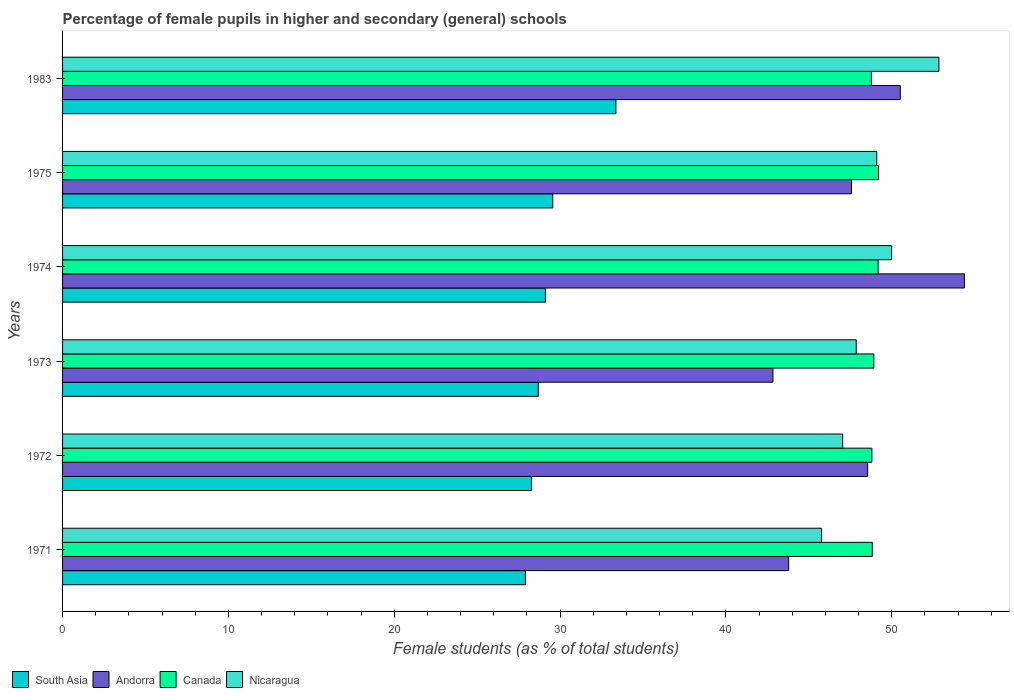Are the number of bars per tick equal to the number of legend labels?
Your response must be concise. Yes. How many bars are there on the 1st tick from the bottom?
Your answer should be compact. 4. What is the label of the 4th group of bars from the top?
Ensure brevity in your answer.  1973. What is the percentage of female pupils in higher and secondary schools in Canada in 1971?
Your answer should be compact. 48.83. Across all years, what is the maximum percentage of female pupils in higher and secondary schools in Nicaragua?
Make the answer very short. 52.85. Across all years, what is the minimum percentage of female pupils in higher and secondary schools in South Asia?
Provide a short and direct response. 27.91. In which year was the percentage of female pupils in higher and secondary schools in Canada maximum?
Ensure brevity in your answer.  1975. In which year was the percentage of female pupils in higher and secondary schools in Andorra minimum?
Offer a terse response. 1973. What is the total percentage of female pupils in higher and secondary schools in Nicaragua in the graph?
Ensure brevity in your answer.  292.6. What is the difference between the percentage of female pupils in higher and secondary schools in Canada in 1973 and that in 1983?
Make the answer very short. 0.15. What is the difference between the percentage of female pupils in higher and secondary schools in Nicaragua in 1971 and the percentage of female pupils in higher and secondary schools in Andorra in 1975?
Offer a terse response. -1.81. What is the average percentage of female pupils in higher and secondary schools in Canada per year?
Make the answer very short. 48.95. In the year 1973, what is the difference between the percentage of female pupils in higher and secondary schools in Andorra and percentage of female pupils in higher and secondary schools in South Asia?
Make the answer very short. 14.15. What is the ratio of the percentage of female pupils in higher and secondary schools in Canada in 1971 to that in 1975?
Your answer should be very brief. 0.99. Is the difference between the percentage of female pupils in higher and secondary schools in Andorra in 1971 and 1972 greater than the difference between the percentage of female pupils in higher and secondary schools in South Asia in 1971 and 1972?
Your answer should be compact. No. What is the difference between the highest and the second highest percentage of female pupils in higher and secondary schools in South Asia?
Your answer should be compact. 3.81. What is the difference between the highest and the lowest percentage of female pupils in higher and secondary schools in Nicaragua?
Make the answer very short. 7.08. In how many years, is the percentage of female pupils in higher and secondary schools in Andorra greater than the average percentage of female pupils in higher and secondary schools in Andorra taken over all years?
Make the answer very short. 3. Is it the case that in every year, the sum of the percentage of female pupils in higher and secondary schools in South Asia and percentage of female pupils in higher and secondary schools in Nicaragua is greater than the sum of percentage of female pupils in higher and secondary schools in Canada and percentage of female pupils in higher and secondary schools in Andorra?
Keep it short and to the point. Yes. What does the 3rd bar from the top in 1974 represents?
Your answer should be compact. Andorra. What does the 3rd bar from the bottom in 1983 represents?
Provide a succinct answer. Canada. Is it the case that in every year, the sum of the percentage of female pupils in higher and secondary schools in Nicaragua and percentage of female pupils in higher and secondary schools in Andorra is greater than the percentage of female pupils in higher and secondary schools in South Asia?
Give a very brief answer. Yes. How many bars are there?
Your answer should be compact. 24. Does the graph contain any zero values?
Provide a succinct answer. No. How many legend labels are there?
Ensure brevity in your answer.  4. How are the legend labels stacked?
Provide a succinct answer. Horizontal. What is the title of the graph?
Make the answer very short. Percentage of female pupils in higher and secondary (general) schools. What is the label or title of the X-axis?
Your answer should be very brief. Female students (as % of total students). What is the label or title of the Y-axis?
Keep it short and to the point. Years. What is the Female students (as % of total students) of South Asia in 1971?
Provide a succinct answer. 27.91. What is the Female students (as % of total students) in Andorra in 1971?
Keep it short and to the point. 43.78. What is the Female students (as % of total students) in Canada in 1971?
Give a very brief answer. 48.83. What is the Female students (as % of total students) of Nicaragua in 1971?
Your answer should be compact. 45.76. What is the Female students (as % of total students) of South Asia in 1972?
Provide a short and direct response. 28.27. What is the Female students (as % of total students) in Andorra in 1972?
Make the answer very short. 48.55. What is the Female students (as % of total students) of Canada in 1972?
Your answer should be compact. 48.8. What is the Female students (as % of total students) of Nicaragua in 1972?
Offer a terse response. 47.04. What is the Female students (as % of total students) of South Asia in 1973?
Your answer should be compact. 28.69. What is the Female students (as % of total students) of Andorra in 1973?
Ensure brevity in your answer.  42.84. What is the Female students (as % of total students) of Canada in 1973?
Give a very brief answer. 48.92. What is the Female students (as % of total students) in Nicaragua in 1973?
Your response must be concise. 47.86. What is the Female students (as % of total students) of South Asia in 1974?
Keep it short and to the point. 29.12. What is the Female students (as % of total students) of Andorra in 1974?
Provide a succinct answer. 54.38. What is the Female students (as % of total students) of Canada in 1974?
Give a very brief answer. 49.18. What is the Female students (as % of total students) in Nicaragua in 1974?
Offer a terse response. 49.99. What is the Female students (as % of total students) in South Asia in 1975?
Your answer should be very brief. 29.56. What is the Female students (as % of total students) of Andorra in 1975?
Make the answer very short. 47.57. What is the Female students (as % of total students) of Canada in 1975?
Provide a succinct answer. 49.21. What is the Female students (as % of total students) in Nicaragua in 1975?
Provide a succinct answer. 49.1. What is the Female students (as % of total students) in South Asia in 1983?
Provide a short and direct response. 33.37. What is the Female students (as % of total students) in Andorra in 1983?
Give a very brief answer. 50.52. What is the Female students (as % of total students) in Canada in 1983?
Provide a succinct answer. 48.77. What is the Female students (as % of total students) of Nicaragua in 1983?
Your response must be concise. 52.85. Across all years, what is the maximum Female students (as % of total students) in South Asia?
Ensure brevity in your answer.  33.37. Across all years, what is the maximum Female students (as % of total students) of Andorra?
Give a very brief answer. 54.38. Across all years, what is the maximum Female students (as % of total students) in Canada?
Ensure brevity in your answer.  49.21. Across all years, what is the maximum Female students (as % of total students) of Nicaragua?
Give a very brief answer. 52.85. Across all years, what is the minimum Female students (as % of total students) in South Asia?
Give a very brief answer. 27.91. Across all years, what is the minimum Female students (as % of total students) in Andorra?
Your answer should be compact. 42.84. Across all years, what is the minimum Female students (as % of total students) in Canada?
Offer a very short reply. 48.77. Across all years, what is the minimum Female students (as % of total students) in Nicaragua?
Make the answer very short. 45.76. What is the total Female students (as % of total students) of South Asia in the graph?
Offer a very short reply. 176.92. What is the total Female students (as % of total students) in Andorra in the graph?
Ensure brevity in your answer.  287.64. What is the total Female students (as % of total students) of Canada in the graph?
Offer a terse response. 293.71. What is the total Female students (as % of total students) in Nicaragua in the graph?
Give a very brief answer. 292.6. What is the difference between the Female students (as % of total students) in South Asia in 1971 and that in 1972?
Give a very brief answer. -0.36. What is the difference between the Female students (as % of total students) of Andorra in 1971 and that in 1972?
Your answer should be very brief. -4.76. What is the difference between the Female students (as % of total students) of Canada in 1971 and that in 1972?
Make the answer very short. 0.03. What is the difference between the Female students (as % of total students) in Nicaragua in 1971 and that in 1972?
Offer a terse response. -1.28. What is the difference between the Female students (as % of total students) in South Asia in 1971 and that in 1973?
Offer a very short reply. -0.78. What is the difference between the Female students (as % of total students) in Andorra in 1971 and that in 1973?
Give a very brief answer. 0.95. What is the difference between the Female students (as % of total students) of Canada in 1971 and that in 1973?
Offer a very short reply. -0.09. What is the difference between the Female students (as % of total students) in Nicaragua in 1971 and that in 1973?
Ensure brevity in your answer.  -2.09. What is the difference between the Female students (as % of total students) of South Asia in 1971 and that in 1974?
Your answer should be very brief. -1.21. What is the difference between the Female students (as % of total students) of Andorra in 1971 and that in 1974?
Your answer should be compact. -10.6. What is the difference between the Female students (as % of total students) of Canada in 1971 and that in 1974?
Provide a succinct answer. -0.35. What is the difference between the Female students (as % of total students) in Nicaragua in 1971 and that in 1974?
Provide a short and direct response. -4.23. What is the difference between the Female students (as % of total students) of South Asia in 1971 and that in 1975?
Your answer should be very brief. -1.65. What is the difference between the Female students (as % of total students) in Andorra in 1971 and that in 1975?
Your answer should be very brief. -3.79. What is the difference between the Female students (as % of total students) in Canada in 1971 and that in 1975?
Keep it short and to the point. -0.38. What is the difference between the Female students (as % of total students) in Nicaragua in 1971 and that in 1975?
Provide a short and direct response. -3.33. What is the difference between the Female students (as % of total students) in South Asia in 1971 and that in 1983?
Offer a very short reply. -5.46. What is the difference between the Female students (as % of total students) in Andorra in 1971 and that in 1983?
Provide a short and direct response. -6.73. What is the difference between the Female students (as % of total students) in Canada in 1971 and that in 1983?
Make the answer very short. 0.06. What is the difference between the Female students (as % of total students) in Nicaragua in 1971 and that in 1983?
Offer a very short reply. -7.08. What is the difference between the Female students (as % of total students) in South Asia in 1972 and that in 1973?
Ensure brevity in your answer.  -0.41. What is the difference between the Female students (as % of total students) in Andorra in 1972 and that in 1973?
Give a very brief answer. 5.71. What is the difference between the Female students (as % of total students) in Canada in 1972 and that in 1973?
Offer a very short reply. -0.12. What is the difference between the Female students (as % of total students) in Nicaragua in 1972 and that in 1973?
Your response must be concise. -0.82. What is the difference between the Female students (as % of total students) of South Asia in 1972 and that in 1974?
Your answer should be very brief. -0.84. What is the difference between the Female students (as % of total students) of Andorra in 1972 and that in 1974?
Offer a very short reply. -5.83. What is the difference between the Female students (as % of total students) of Canada in 1972 and that in 1974?
Your response must be concise. -0.38. What is the difference between the Female students (as % of total students) of Nicaragua in 1972 and that in 1974?
Your answer should be very brief. -2.95. What is the difference between the Female students (as % of total students) in South Asia in 1972 and that in 1975?
Your answer should be very brief. -1.29. What is the difference between the Female students (as % of total students) in Andorra in 1972 and that in 1975?
Make the answer very short. 0.97. What is the difference between the Female students (as % of total students) in Canada in 1972 and that in 1975?
Make the answer very short. -0.4. What is the difference between the Female students (as % of total students) of Nicaragua in 1972 and that in 1975?
Make the answer very short. -2.06. What is the difference between the Female students (as % of total students) of South Asia in 1972 and that in 1983?
Provide a succinct answer. -5.09. What is the difference between the Female students (as % of total students) in Andorra in 1972 and that in 1983?
Your answer should be compact. -1.97. What is the difference between the Female students (as % of total students) of Canada in 1972 and that in 1983?
Provide a short and direct response. 0.03. What is the difference between the Female students (as % of total students) of Nicaragua in 1972 and that in 1983?
Ensure brevity in your answer.  -5.8. What is the difference between the Female students (as % of total students) in South Asia in 1973 and that in 1974?
Give a very brief answer. -0.43. What is the difference between the Female students (as % of total students) in Andorra in 1973 and that in 1974?
Your answer should be very brief. -11.55. What is the difference between the Female students (as % of total students) of Canada in 1973 and that in 1974?
Provide a succinct answer. -0.26. What is the difference between the Female students (as % of total students) of Nicaragua in 1973 and that in 1974?
Offer a very short reply. -2.13. What is the difference between the Female students (as % of total students) in South Asia in 1973 and that in 1975?
Offer a very short reply. -0.87. What is the difference between the Female students (as % of total students) in Andorra in 1973 and that in 1975?
Keep it short and to the point. -4.74. What is the difference between the Female students (as % of total students) of Canada in 1973 and that in 1975?
Provide a succinct answer. -0.28. What is the difference between the Female students (as % of total students) of Nicaragua in 1973 and that in 1975?
Keep it short and to the point. -1.24. What is the difference between the Female students (as % of total students) of South Asia in 1973 and that in 1983?
Provide a short and direct response. -4.68. What is the difference between the Female students (as % of total students) in Andorra in 1973 and that in 1983?
Make the answer very short. -7.68. What is the difference between the Female students (as % of total students) in Canada in 1973 and that in 1983?
Your answer should be very brief. 0.15. What is the difference between the Female students (as % of total students) of Nicaragua in 1973 and that in 1983?
Your answer should be very brief. -4.99. What is the difference between the Female students (as % of total students) in South Asia in 1974 and that in 1975?
Make the answer very short. -0.44. What is the difference between the Female students (as % of total students) of Andorra in 1974 and that in 1975?
Make the answer very short. 6.81. What is the difference between the Female students (as % of total students) in Canada in 1974 and that in 1975?
Your answer should be compact. -0.03. What is the difference between the Female students (as % of total students) of Nicaragua in 1974 and that in 1975?
Offer a terse response. 0.9. What is the difference between the Female students (as % of total students) of South Asia in 1974 and that in 1983?
Offer a terse response. -4.25. What is the difference between the Female students (as % of total students) of Andorra in 1974 and that in 1983?
Offer a very short reply. 3.87. What is the difference between the Female students (as % of total students) of Canada in 1974 and that in 1983?
Offer a very short reply. 0.41. What is the difference between the Female students (as % of total students) of Nicaragua in 1974 and that in 1983?
Your answer should be compact. -2.85. What is the difference between the Female students (as % of total students) of South Asia in 1975 and that in 1983?
Make the answer very short. -3.81. What is the difference between the Female students (as % of total students) of Andorra in 1975 and that in 1983?
Give a very brief answer. -2.94. What is the difference between the Female students (as % of total students) of Canada in 1975 and that in 1983?
Offer a terse response. 0.43. What is the difference between the Female students (as % of total students) in Nicaragua in 1975 and that in 1983?
Provide a short and direct response. -3.75. What is the difference between the Female students (as % of total students) of South Asia in 1971 and the Female students (as % of total students) of Andorra in 1972?
Offer a terse response. -20.64. What is the difference between the Female students (as % of total students) of South Asia in 1971 and the Female students (as % of total students) of Canada in 1972?
Offer a terse response. -20.89. What is the difference between the Female students (as % of total students) in South Asia in 1971 and the Female students (as % of total students) in Nicaragua in 1972?
Give a very brief answer. -19.13. What is the difference between the Female students (as % of total students) in Andorra in 1971 and the Female students (as % of total students) in Canada in 1972?
Offer a very short reply. -5.02. What is the difference between the Female students (as % of total students) in Andorra in 1971 and the Female students (as % of total students) in Nicaragua in 1972?
Your answer should be very brief. -3.26. What is the difference between the Female students (as % of total students) of Canada in 1971 and the Female students (as % of total students) of Nicaragua in 1972?
Ensure brevity in your answer.  1.79. What is the difference between the Female students (as % of total students) in South Asia in 1971 and the Female students (as % of total students) in Andorra in 1973?
Ensure brevity in your answer.  -14.93. What is the difference between the Female students (as % of total students) in South Asia in 1971 and the Female students (as % of total students) in Canada in 1973?
Ensure brevity in your answer.  -21.01. What is the difference between the Female students (as % of total students) in South Asia in 1971 and the Female students (as % of total students) in Nicaragua in 1973?
Make the answer very short. -19.95. What is the difference between the Female students (as % of total students) in Andorra in 1971 and the Female students (as % of total students) in Canada in 1973?
Make the answer very short. -5.14. What is the difference between the Female students (as % of total students) of Andorra in 1971 and the Female students (as % of total students) of Nicaragua in 1973?
Offer a terse response. -4.07. What is the difference between the Female students (as % of total students) in Canada in 1971 and the Female students (as % of total students) in Nicaragua in 1973?
Keep it short and to the point. 0.97. What is the difference between the Female students (as % of total students) in South Asia in 1971 and the Female students (as % of total students) in Andorra in 1974?
Make the answer very short. -26.47. What is the difference between the Female students (as % of total students) of South Asia in 1971 and the Female students (as % of total students) of Canada in 1974?
Provide a succinct answer. -21.27. What is the difference between the Female students (as % of total students) of South Asia in 1971 and the Female students (as % of total students) of Nicaragua in 1974?
Your response must be concise. -22.08. What is the difference between the Female students (as % of total students) in Andorra in 1971 and the Female students (as % of total students) in Canada in 1974?
Your answer should be very brief. -5.4. What is the difference between the Female students (as % of total students) in Andorra in 1971 and the Female students (as % of total students) in Nicaragua in 1974?
Your answer should be very brief. -6.21. What is the difference between the Female students (as % of total students) of Canada in 1971 and the Female students (as % of total students) of Nicaragua in 1974?
Make the answer very short. -1.16. What is the difference between the Female students (as % of total students) in South Asia in 1971 and the Female students (as % of total students) in Andorra in 1975?
Keep it short and to the point. -19.66. What is the difference between the Female students (as % of total students) of South Asia in 1971 and the Female students (as % of total students) of Canada in 1975?
Your response must be concise. -21.29. What is the difference between the Female students (as % of total students) of South Asia in 1971 and the Female students (as % of total students) of Nicaragua in 1975?
Make the answer very short. -21.19. What is the difference between the Female students (as % of total students) in Andorra in 1971 and the Female students (as % of total students) in Canada in 1975?
Offer a terse response. -5.42. What is the difference between the Female students (as % of total students) in Andorra in 1971 and the Female students (as % of total students) in Nicaragua in 1975?
Provide a short and direct response. -5.31. What is the difference between the Female students (as % of total students) in Canada in 1971 and the Female students (as % of total students) in Nicaragua in 1975?
Make the answer very short. -0.27. What is the difference between the Female students (as % of total students) in South Asia in 1971 and the Female students (as % of total students) in Andorra in 1983?
Offer a very short reply. -22.61. What is the difference between the Female students (as % of total students) in South Asia in 1971 and the Female students (as % of total students) in Canada in 1983?
Offer a very short reply. -20.86. What is the difference between the Female students (as % of total students) of South Asia in 1971 and the Female students (as % of total students) of Nicaragua in 1983?
Provide a succinct answer. -24.94. What is the difference between the Female students (as % of total students) of Andorra in 1971 and the Female students (as % of total students) of Canada in 1983?
Keep it short and to the point. -4.99. What is the difference between the Female students (as % of total students) of Andorra in 1971 and the Female students (as % of total students) of Nicaragua in 1983?
Offer a terse response. -9.06. What is the difference between the Female students (as % of total students) in Canada in 1971 and the Female students (as % of total students) in Nicaragua in 1983?
Your answer should be compact. -4.02. What is the difference between the Female students (as % of total students) in South Asia in 1972 and the Female students (as % of total students) in Andorra in 1973?
Your answer should be very brief. -14.56. What is the difference between the Female students (as % of total students) in South Asia in 1972 and the Female students (as % of total students) in Canada in 1973?
Give a very brief answer. -20.65. What is the difference between the Female students (as % of total students) in South Asia in 1972 and the Female students (as % of total students) in Nicaragua in 1973?
Make the answer very short. -19.58. What is the difference between the Female students (as % of total students) in Andorra in 1972 and the Female students (as % of total students) in Canada in 1973?
Make the answer very short. -0.37. What is the difference between the Female students (as % of total students) of Andorra in 1972 and the Female students (as % of total students) of Nicaragua in 1973?
Provide a succinct answer. 0.69. What is the difference between the Female students (as % of total students) in Canada in 1972 and the Female students (as % of total students) in Nicaragua in 1973?
Offer a terse response. 0.94. What is the difference between the Female students (as % of total students) in South Asia in 1972 and the Female students (as % of total students) in Andorra in 1974?
Your answer should be compact. -26.11. What is the difference between the Female students (as % of total students) in South Asia in 1972 and the Female students (as % of total students) in Canada in 1974?
Your response must be concise. -20.91. What is the difference between the Female students (as % of total students) of South Asia in 1972 and the Female students (as % of total students) of Nicaragua in 1974?
Make the answer very short. -21.72. What is the difference between the Female students (as % of total students) in Andorra in 1972 and the Female students (as % of total students) in Canada in 1974?
Your response must be concise. -0.63. What is the difference between the Female students (as % of total students) in Andorra in 1972 and the Female students (as % of total students) in Nicaragua in 1974?
Keep it short and to the point. -1.45. What is the difference between the Female students (as % of total students) in Canada in 1972 and the Female students (as % of total students) in Nicaragua in 1974?
Make the answer very short. -1.19. What is the difference between the Female students (as % of total students) of South Asia in 1972 and the Female students (as % of total students) of Andorra in 1975?
Your response must be concise. -19.3. What is the difference between the Female students (as % of total students) of South Asia in 1972 and the Female students (as % of total students) of Canada in 1975?
Keep it short and to the point. -20.93. What is the difference between the Female students (as % of total students) of South Asia in 1972 and the Female students (as % of total students) of Nicaragua in 1975?
Provide a short and direct response. -20.82. What is the difference between the Female students (as % of total students) of Andorra in 1972 and the Female students (as % of total students) of Canada in 1975?
Your response must be concise. -0.66. What is the difference between the Female students (as % of total students) in Andorra in 1972 and the Female students (as % of total students) in Nicaragua in 1975?
Provide a succinct answer. -0.55. What is the difference between the Female students (as % of total students) in Canada in 1972 and the Female students (as % of total students) in Nicaragua in 1975?
Your answer should be compact. -0.3. What is the difference between the Female students (as % of total students) of South Asia in 1972 and the Female students (as % of total students) of Andorra in 1983?
Provide a succinct answer. -22.24. What is the difference between the Female students (as % of total students) in South Asia in 1972 and the Female students (as % of total students) in Canada in 1983?
Provide a short and direct response. -20.5. What is the difference between the Female students (as % of total students) in South Asia in 1972 and the Female students (as % of total students) in Nicaragua in 1983?
Give a very brief answer. -24.57. What is the difference between the Female students (as % of total students) of Andorra in 1972 and the Female students (as % of total students) of Canada in 1983?
Provide a succinct answer. -0.22. What is the difference between the Female students (as % of total students) in Andorra in 1972 and the Female students (as % of total students) in Nicaragua in 1983?
Offer a terse response. -4.3. What is the difference between the Female students (as % of total students) in Canada in 1972 and the Female students (as % of total students) in Nicaragua in 1983?
Keep it short and to the point. -4.04. What is the difference between the Female students (as % of total students) of South Asia in 1973 and the Female students (as % of total students) of Andorra in 1974?
Offer a very short reply. -25.69. What is the difference between the Female students (as % of total students) in South Asia in 1973 and the Female students (as % of total students) in Canada in 1974?
Give a very brief answer. -20.49. What is the difference between the Female students (as % of total students) of South Asia in 1973 and the Female students (as % of total students) of Nicaragua in 1974?
Your response must be concise. -21.3. What is the difference between the Female students (as % of total students) of Andorra in 1973 and the Female students (as % of total students) of Canada in 1974?
Your answer should be compact. -6.34. What is the difference between the Female students (as % of total students) in Andorra in 1973 and the Female students (as % of total students) in Nicaragua in 1974?
Offer a very short reply. -7.16. What is the difference between the Female students (as % of total students) of Canada in 1973 and the Female students (as % of total students) of Nicaragua in 1974?
Give a very brief answer. -1.07. What is the difference between the Female students (as % of total students) of South Asia in 1973 and the Female students (as % of total students) of Andorra in 1975?
Offer a terse response. -18.88. What is the difference between the Female students (as % of total students) in South Asia in 1973 and the Female students (as % of total students) in Canada in 1975?
Ensure brevity in your answer.  -20.52. What is the difference between the Female students (as % of total students) of South Asia in 1973 and the Female students (as % of total students) of Nicaragua in 1975?
Your answer should be very brief. -20.41. What is the difference between the Female students (as % of total students) in Andorra in 1973 and the Female students (as % of total students) in Canada in 1975?
Your response must be concise. -6.37. What is the difference between the Female students (as % of total students) of Andorra in 1973 and the Female students (as % of total students) of Nicaragua in 1975?
Your answer should be very brief. -6.26. What is the difference between the Female students (as % of total students) of Canada in 1973 and the Female students (as % of total students) of Nicaragua in 1975?
Keep it short and to the point. -0.18. What is the difference between the Female students (as % of total students) of South Asia in 1973 and the Female students (as % of total students) of Andorra in 1983?
Provide a succinct answer. -21.83. What is the difference between the Female students (as % of total students) of South Asia in 1973 and the Female students (as % of total students) of Canada in 1983?
Offer a very short reply. -20.08. What is the difference between the Female students (as % of total students) of South Asia in 1973 and the Female students (as % of total students) of Nicaragua in 1983?
Offer a terse response. -24.16. What is the difference between the Female students (as % of total students) in Andorra in 1973 and the Female students (as % of total students) in Canada in 1983?
Your answer should be compact. -5.93. What is the difference between the Female students (as % of total students) in Andorra in 1973 and the Female students (as % of total students) in Nicaragua in 1983?
Your answer should be very brief. -10.01. What is the difference between the Female students (as % of total students) of Canada in 1973 and the Female students (as % of total students) of Nicaragua in 1983?
Make the answer very short. -3.92. What is the difference between the Female students (as % of total students) of South Asia in 1974 and the Female students (as % of total students) of Andorra in 1975?
Give a very brief answer. -18.46. What is the difference between the Female students (as % of total students) of South Asia in 1974 and the Female students (as % of total students) of Canada in 1975?
Provide a short and direct response. -20.09. What is the difference between the Female students (as % of total students) in South Asia in 1974 and the Female students (as % of total students) in Nicaragua in 1975?
Give a very brief answer. -19.98. What is the difference between the Female students (as % of total students) in Andorra in 1974 and the Female students (as % of total students) in Canada in 1975?
Your answer should be very brief. 5.18. What is the difference between the Female students (as % of total students) in Andorra in 1974 and the Female students (as % of total students) in Nicaragua in 1975?
Your response must be concise. 5.28. What is the difference between the Female students (as % of total students) in Canada in 1974 and the Female students (as % of total students) in Nicaragua in 1975?
Give a very brief answer. 0.08. What is the difference between the Female students (as % of total students) of South Asia in 1974 and the Female students (as % of total students) of Andorra in 1983?
Offer a terse response. -21.4. What is the difference between the Female students (as % of total students) of South Asia in 1974 and the Female students (as % of total students) of Canada in 1983?
Your response must be concise. -19.65. What is the difference between the Female students (as % of total students) of South Asia in 1974 and the Female students (as % of total students) of Nicaragua in 1983?
Keep it short and to the point. -23.73. What is the difference between the Female students (as % of total students) of Andorra in 1974 and the Female students (as % of total students) of Canada in 1983?
Give a very brief answer. 5.61. What is the difference between the Female students (as % of total students) in Andorra in 1974 and the Female students (as % of total students) in Nicaragua in 1983?
Your response must be concise. 1.54. What is the difference between the Female students (as % of total students) of Canada in 1974 and the Female students (as % of total students) of Nicaragua in 1983?
Your answer should be compact. -3.67. What is the difference between the Female students (as % of total students) of South Asia in 1975 and the Female students (as % of total students) of Andorra in 1983?
Your response must be concise. -20.96. What is the difference between the Female students (as % of total students) of South Asia in 1975 and the Female students (as % of total students) of Canada in 1983?
Provide a short and direct response. -19.21. What is the difference between the Female students (as % of total students) of South Asia in 1975 and the Female students (as % of total students) of Nicaragua in 1983?
Offer a terse response. -23.29. What is the difference between the Female students (as % of total students) in Andorra in 1975 and the Female students (as % of total students) in Canada in 1983?
Provide a short and direct response. -1.2. What is the difference between the Female students (as % of total students) of Andorra in 1975 and the Female students (as % of total students) of Nicaragua in 1983?
Your answer should be compact. -5.27. What is the difference between the Female students (as % of total students) in Canada in 1975 and the Female students (as % of total students) in Nicaragua in 1983?
Your answer should be very brief. -3.64. What is the average Female students (as % of total students) in South Asia per year?
Make the answer very short. 29.49. What is the average Female students (as % of total students) of Andorra per year?
Your answer should be compact. 47.94. What is the average Female students (as % of total students) in Canada per year?
Your answer should be compact. 48.95. What is the average Female students (as % of total students) of Nicaragua per year?
Make the answer very short. 48.77. In the year 1971, what is the difference between the Female students (as % of total students) of South Asia and Female students (as % of total students) of Andorra?
Your answer should be very brief. -15.87. In the year 1971, what is the difference between the Female students (as % of total students) of South Asia and Female students (as % of total students) of Canada?
Ensure brevity in your answer.  -20.92. In the year 1971, what is the difference between the Female students (as % of total students) in South Asia and Female students (as % of total students) in Nicaragua?
Offer a very short reply. -17.85. In the year 1971, what is the difference between the Female students (as % of total students) of Andorra and Female students (as % of total students) of Canada?
Your answer should be very brief. -5.04. In the year 1971, what is the difference between the Female students (as % of total students) in Andorra and Female students (as % of total students) in Nicaragua?
Provide a short and direct response. -1.98. In the year 1971, what is the difference between the Female students (as % of total students) in Canada and Female students (as % of total students) in Nicaragua?
Your answer should be compact. 3.06. In the year 1972, what is the difference between the Female students (as % of total students) in South Asia and Female students (as % of total students) in Andorra?
Offer a very short reply. -20.27. In the year 1972, what is the difference between the Female students (as % of total students) of South Asia and Female students (as % of total students) of Canada?
Ensure brevity in your answer.  -20.53. In the year 1972, what is the difference between the Female students (as % of total students) of South Asia and Female students (as % of total students) of Nicaragua?
Give a very brief answer. -18.77. In the year 1972, what is the difference between the Female students (as % of total students) in Andorra and Female students (as % of total students) in Canada?
Provide a short and direct response. -0.25. In the year 1972, what is the difference between the Female students (as % of total students) in Andorra and Female students (as % of total students) in Nicaragua?
Offer a terse response. 1.51. In the year 1972, what is the difference between the Female students (as % of total students) of Canada and Female students (as % of total students) of Nicaragua?
Your answer should be very brief. 1.76. In the year 1973, what is the difference between the Female students (as % of total students) in South Asia and Female students (as % of total students) in Andorra?
Offer a terse response. -14.15. In the year 1973, what is the difference between the Female students (as % of total students) in South Asia and Female students (as % of total students) in Canada?
Offer a terse response. -20.23. In the year 1973, what is the difference between the Female students (as % of total students) of South Asia and Female students (as % of total students) of Nicaragua?
Ensure brevity in your answer.  -19.17. In the year 1973, what is the difference between the Female students (as % of total students) in Andorra and Female students (as % of total students) in Canada?
Provide a succinct answer. -6.08. In the year 1973, what is the difference between the Female students (as % of total students) in Andorra and Female students (as % of total students) in Nicaragua?
Your response must be concise. -5.02. In the year 1973, what is the difference between the Female students (as % of total students) of Canada and Female students (as % of total students) of Nicaragua?
Make the answer very short. 1.06. In the year 1974, what is the difference between the Female students (as % of total students) of South Asia and Female students (as % of total students) of Andorra?
Offer a terse response. -25.27. In the year 1974, what is the difference between the Female students (as % of total students) in South Asia and Female students (as % of total students) in Canada?
Ensure brevity in your answer.  -20.06. In the year 1974, what is the difference between the Female students (as % of total students) in South Asia and Female students (as % of total students) in Nicaragua?
Your answer should be compact. -20.88. In the year 1974, what is the difference between the Female students (as % of total students) of Andorra and Female students (as % of total students) of Canada?
Provide a short and direct response. 5.2. In the year 1974, what is the difference between the Female students (as % of total students) in Andorra and Female students (as % of total students) in Nicaragua?
Ensure brevity in your answer.  4.39. In the year 1974, what is the difference between the Female students (as % of total students) in Canada and Female students (as % of total students) in Nicaragua?
Your answer should be compact. -0.81. In the year 1975, what is the difference between the Female students (as % of total students) of South Asia and Female students (as % of total students) of Andorra?
Your answer should be very brief. -18.01. In the year 1975, what is the difference between the Female students (as % of total students) of South Asia and Female students (as % of total students) of Canada?
Your answer should be compact. -19.64. In the year 1975, what is the difference between the Female students (as % of total students) in South Asia and Female students (as % of total students) in Nicaragua?
Your response must be concise. -19.54. In the year 1975, what is the difference between the Female students (as % of total students) of Andorra and Female students (as % of total students) of Canada?
Give a very brief answer. -1.63. In the year 1975, what is the difference between the Female students (as % of total students) in Andorra and Female students (as % of total students) in Nicaragua?
Your answer should be compact. -1.53. In the year 1975, what is the difference between the Female students (as % of total students) in Canada and Female students (as % of total students) in Nicaragua?
Your answer should be compact. 0.11. In the year 1983, what is the difference between the Female students (as % of total students) in South Asia and Female students (as % of total students) in Andorra?
Your answer should be very brief. -17.15. In the year 1983, what is the difference between the Female students (as % of total students) in South Asia and Female students (as % of total students) in Canada?
Your answer should be compact. -15.4. In the year 1983, what is the difference between the Female students (as % of total students) of South Asia and Female students (as % of total students) of Nicaragua?
Make the answer very short. -19.48. In the year 1983, what is the difference between the Female students (as % of total students) in Andorra and Female students (as % of total students) in Canada?
Provide a succinct answer. 1.75. In the year 1983, what is the difference between the Female students (as % of total students) of Andorra and Female students (as % of total students) of Nicaragua?
Give a very brief answer. -2.33. In the year 1983, what is the difference between the Female students (as % of total students) of Canada and Female students (as % of total students) of Nicaragua?
Your response must be concise. -4.07. What is the ratio of the Female students (as % of total students) in South Asia in 1971 to that in 1972?
Provide a succinct answer. 0.99. What is the ratio of the Female students (as % of total students) in Andorra in 1971 to that in 1972?
Give a very brief answer. 0.9. What is the ratio of the Female students (as % of total students) in Nicaragua in 1971 to that in 1972?
Keep it short and to the point. 0.97. What is the ratio of the Female students (as % of total students) of South Asia in 1971 to that in 1973?
Offer a terse response. 0.97. What is the ratio of the Female students (as % of total students) of Andorra in 1971 to that in 1973?
Your answer should be compact. 1.02. What is the ratio of the Female students (as % of total students) in Nicaragua in 1971 to that in 1973?
Provide a short and direct response. 0.96. What is the ratio of the Female students (as % of total students) of South Asia in 1971 to that in 1974?
Ensure brevity in your answer.  0.96. What is the ratio of the Female students (as % of total students) of Andorra in 1971 to that in 1974?
Offer a very short reply. 0.81. What is the ratio of the Female students (as % of total students) of Canada in 1971 to that in 1974?
Ensure brevity in your answer.  0.99. What is the ratio of the Female students (as % of total students) in Nicaragua in 1971 to that in 1974?
Keep it short and to the point. 0.92. What is the ratio of the Female students (as % of total students) of South Asia in 1971 to that in 1975?
Ensure brevity in your answer.  0.94. What is the ratio of the Female students (as % of total students) of Andorra in 1971 to that in 1975?
Your answer should be compact. 0.92. What is the ratio of the Female students (as % of total students) of Nicaragua in 1971 to that in 1975?
Your answer should be compact. 0.93. What is the ratio of the Female students (as % of total students) of South Asia in 1971 to that in 1983?
Give a very brief answer. 0.84. What is the ratio of the Female students (as % of total students) in Andorra in 1971 to that in 1983?
Ensure brevity in your answer.  0.87. What is the ratio of the Female students (as % of total students) of Canada in 1971 to that in 1983?
Your response must be concise. 1. What is the ratio of the Female students (as % of total students) of Nicaragua in 1971 to that in 1983?
Keep it short and to the point. 0.87. What is the ratio of the Female students (as % of total students) of South Asia in 1972 to that in 1973?
Your response must be concise. 0.99. What is the ratio of the Female students (as % of total students) of Andorra in 1972 to that in 1973?
Make the answer very short. 1.13. What is the ratio of the Female students (as % of total students) in Canada in 1972 to that in 1973?
Give a very brief answer. 1. What is the ratio of the Female students (as % of total students) of Nicaragua in 1972 to that in 1973?
Make the answer very short. 0.98. What is the ratio of the Female students (as % of total students) in South Asia in 1972 to that in 1974?
Your response must be concise. 0.97. What is the ratio of the Female students (as % of total students) in Andorra in 1972 to that in 1974?
Your answer should be very brief. 0.89. What is the ratio of the Female students (as % of total students) in Nicaragua in 1972 to that in 1974?
Your answer should be very brief. 0.94. What is the ratio of the Female students (as % of total students) of South Asia in 1972 to that in 1975?
Your response must be concise. 0.96. What is the ratio of the Female students (as % of total students) of Andorra in 1972 to that in 1975?
Provide a succinct answer. 1.02. What is the ratio of the Female students (as % of total students) in Nicaragua in 1972 to that in 1975?
Offer a very short reply. 0.96. What is the ratio of the Female students (as % of total students) of South Asia in 1972 to that in 1983?
Your response must be concise. 0.85. What is the ratio of the Female students (as % of total students) in Nicaragua in 1972 to that in 1983?
Make the answer very short. 0.89. What is the ratio of the Female students (as % of total students) in South Asia in 1973 to that in 1974?
Provide a short and direct response. 0.99. What is the ratio of the Female students (as % of total students) in Andorra in 1973 to that in 1974?
Offer a terse response. 0.79. What is the ratio of the Female students (as % of total students) of Nicaragua in 1973 to that in 1974?
Provide a succinct answer. 0.96. What is the ratio of the Female students (as % of total students) in South Asia in 1973 to that in 1975?
Your response must be concise. 0.97. What is the ratio of the Female students (as % of total students) in Andorra in 1973 to that in 1975?
Offer a very short reply. 0.9. What is the ratio of the Female students (as % of total students) of Canada in 1973 to that in 1975?
Keep it short and to the point. 0.99. What is the ratio of the Female students (as % of total students) of Nicaragua in 1973 to that in 1975?
Your response must be concise. 0.97. What is the ratio of the Female students (as % of total students) of South Asia in 1973 to that in 1983?
Give a very brief answer. 0.86. What is the ratio of the Female students (as % of total students) in Andorra in 1973 to that in 1983?
Provide a succinct answer. 0.85. What is the ratio of the Female students (as % of total students) in Canada in 1973 to that in 1983?
Offer a very short reply. 1. What is the ratio of the Female students (as % of total students) of Nicaragua in 1973 to that in 1983?
Give a very brief answer. 0.91. What is the ratio of the Female students (as % of total students) of South Asia in 1974 to that in 1975?
Provide a succinct answer. 0.98. What is the ratio of the Female students (as % of total students) in Andorra in 1974 to that in 1975?
Make the answer very short. 1.14. What is the ratio of the Female students (as % of total students) in Canada in 1974 to that in 1975?
Provide a short and direct response. 1. What is the ratio of the Female students (as % of total students) of Nicaragua in 1974 to that in 1975?
Your answer should be compact. 1.02. What is the ratio of the Female students (as % of total students) in South Asia in 1974 to that in 1983?
Make the answer very short. 0.87. What is the ratio of the Female students (as % of total students) of Andorra in 1974 to that in 1983?
Give a very brief answer. 1.08. What is the ratio of the Female students (as % of total students) of Canada in 1974 to that in 1983?
Offer a very short reply. 1.01. What is the ratio of the Female students (as % of total students) in Nicaragua in 1974 to that in 1983?
Ensure brevity in your answer.  0.95. What is the ratio of the Female students (as % of total students) in South Asia in 1975 to that in 1983?
Provide a short and direct response. 0.89. What is the ratio of the Female students (as % of total students) of Andorra in 1975 to that in 1983?
Your answer should be compact. 0.94. What is the ratio of the Female students (as % of total students) of Canada in 1975 to that in 1983?
Keep it short and to the point. 1.01. What is the ratio of the Female students (as % of total students) in Nicaragua in 1975 to that in 1983?
Keep it short and to the point. 0.93. What is the difference between the highest and the second highest Female students (as % of total students) in South Asia?
Provide a short and direct response. 3.81. What is the difference between the highest and the second highest Female students (as % of total students) in Andorra?
Offer a terse response. 3.87. What is the difference between the highest and the second highest Female students (as % of total students) of Canada?
Offer a very short reply. 0.03. What is the difference between the highest and the second highest Female students (as % of total students) in Nicaragua?
Keep it short and to the point. 2.85. What is the difference between the highest and the lowest Female students (as % of total students) of South Asia?
Offer a very short reply. 5.46. What is the difference between the highest and the lowest Female students (as % of total students) in Andorra?
Offer a terse response. 11.55. What is the difference between the highest and the lowest Female students (as % of total students) in Canada?
Give a very brief answer. 0.43. What is the difference between the highest and the lowest Female students (as % of total students) in Nicaragua?
Give a very brief answer. 7.08. 